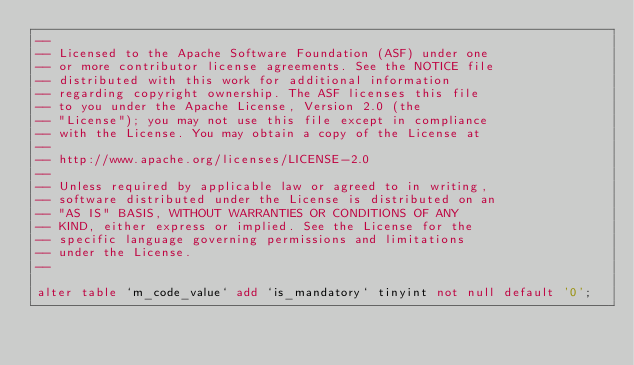Convert code to text. <code><loc_0><loc_0><loc_500><loc_500><_SQL_>--
-- Licensed to the Apache Software Foundation (ASF) under one
-- or more contributor license agreements. See the NOTICE file
-- distributed with this work for additional information
-- regarding copyright ownership. The ASF licenses this file
-- to you under the Apache License, Version 2.0 (the
-- "License"); you may not use this file except in compliance
-- with the License. You may obtain a copy of the License at
--
-- http://www.apache.org/licenses/LICENSE-2.0
--
-- Unless required by applicable law or agreed to in writing,
-- software distributed under the License is distributed on an
-- "AS IS" BASIS, WITHOUT WARRANTIES OR CONDITIONS OF ANY
-- KIND, either express or implied. See the License for the
-- specific language governing permissions and limitations
-- under the License.
--

alter table `m_code_value` add `is_mandatory` tinyint not null default '0'; 
</code> 